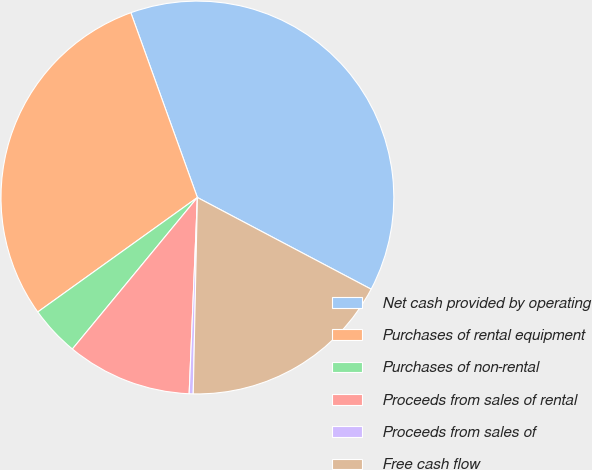Convert chart to OTSL. <chart><loc_0><loc_0><loc_500><loc_500><pie_chart><fcel>Net cash provided by operating<fcel>Purchases of rental equipment<fcel>Purchases of non-rental<fcel>Proceeds from sales of rental<fcel>Proceeds from sales of<fcel>Free cash flow<nl><fcel>38.23%<fcel>29.4%<fcel>4.12%<fcel>10.31%<fcel>0.33%<fcel>17.61%<nl></chart> 